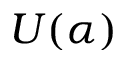<formula> <loc_0><loc_0><loc_500><loc_500>U ( \alpha )</formula> 